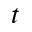<formula> <loc_0><loc_0><loc_500><loc_500>t</formula> 